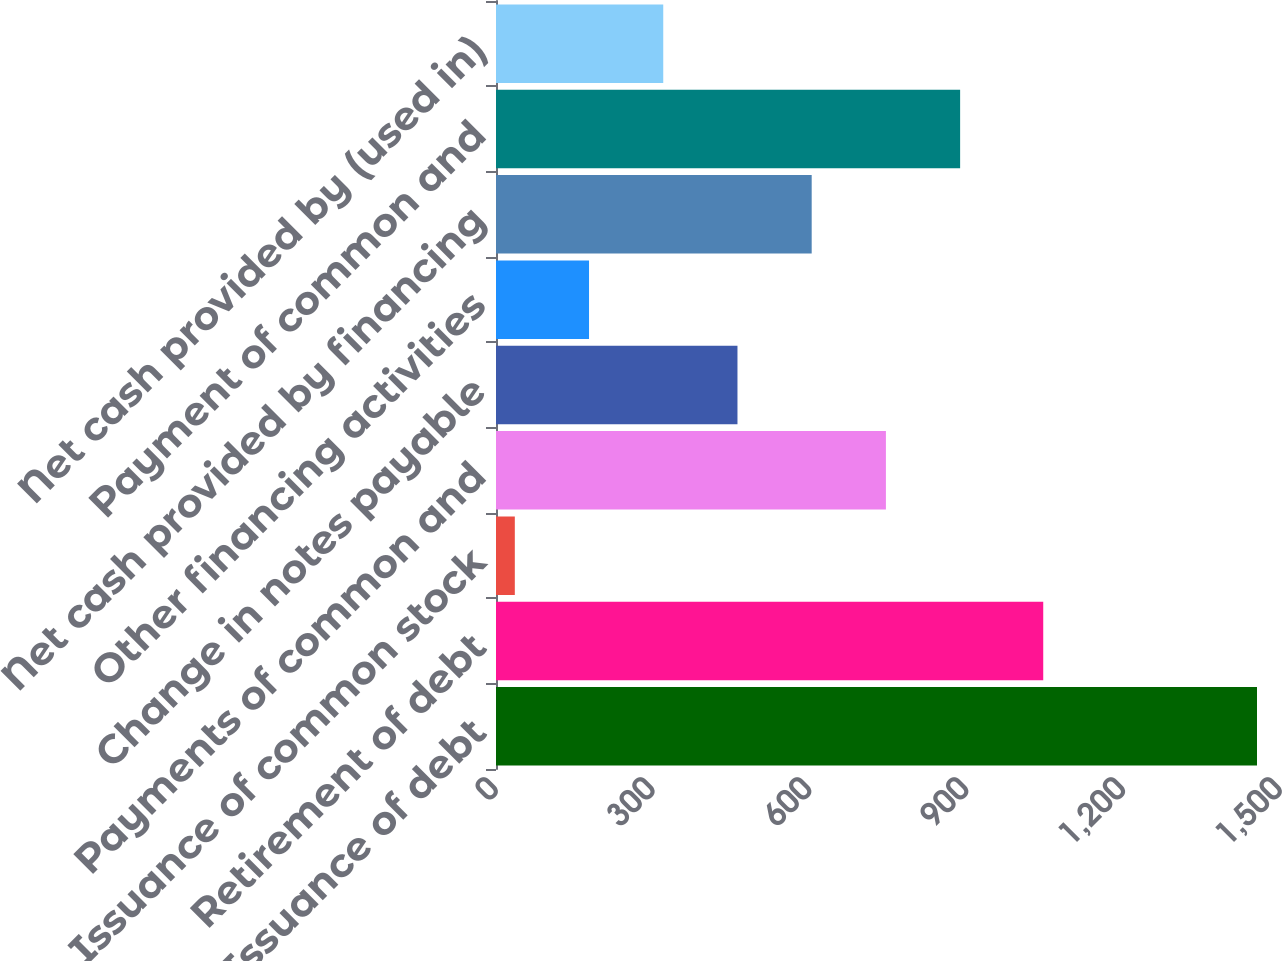<chart> <loc_0><loc_0><loc_500><loc_500><bar_chart><fcel>Issuance of debt<fcel>Retirement of debt<fcel>Issuance of common stock<fcel>Payments of common and<fcel>Change in notes payable<fcel>Other financing activities<fcel>Net cash provided by financing<fcel>Payment of common and<fcel>Net cash provided by (used in)<nl><fcel>1456<fcel>1047<fcel>36<fcel>746<fcel>462<fcel>178<fcel>604<fcel>888<fcel>320<nl></chart> 